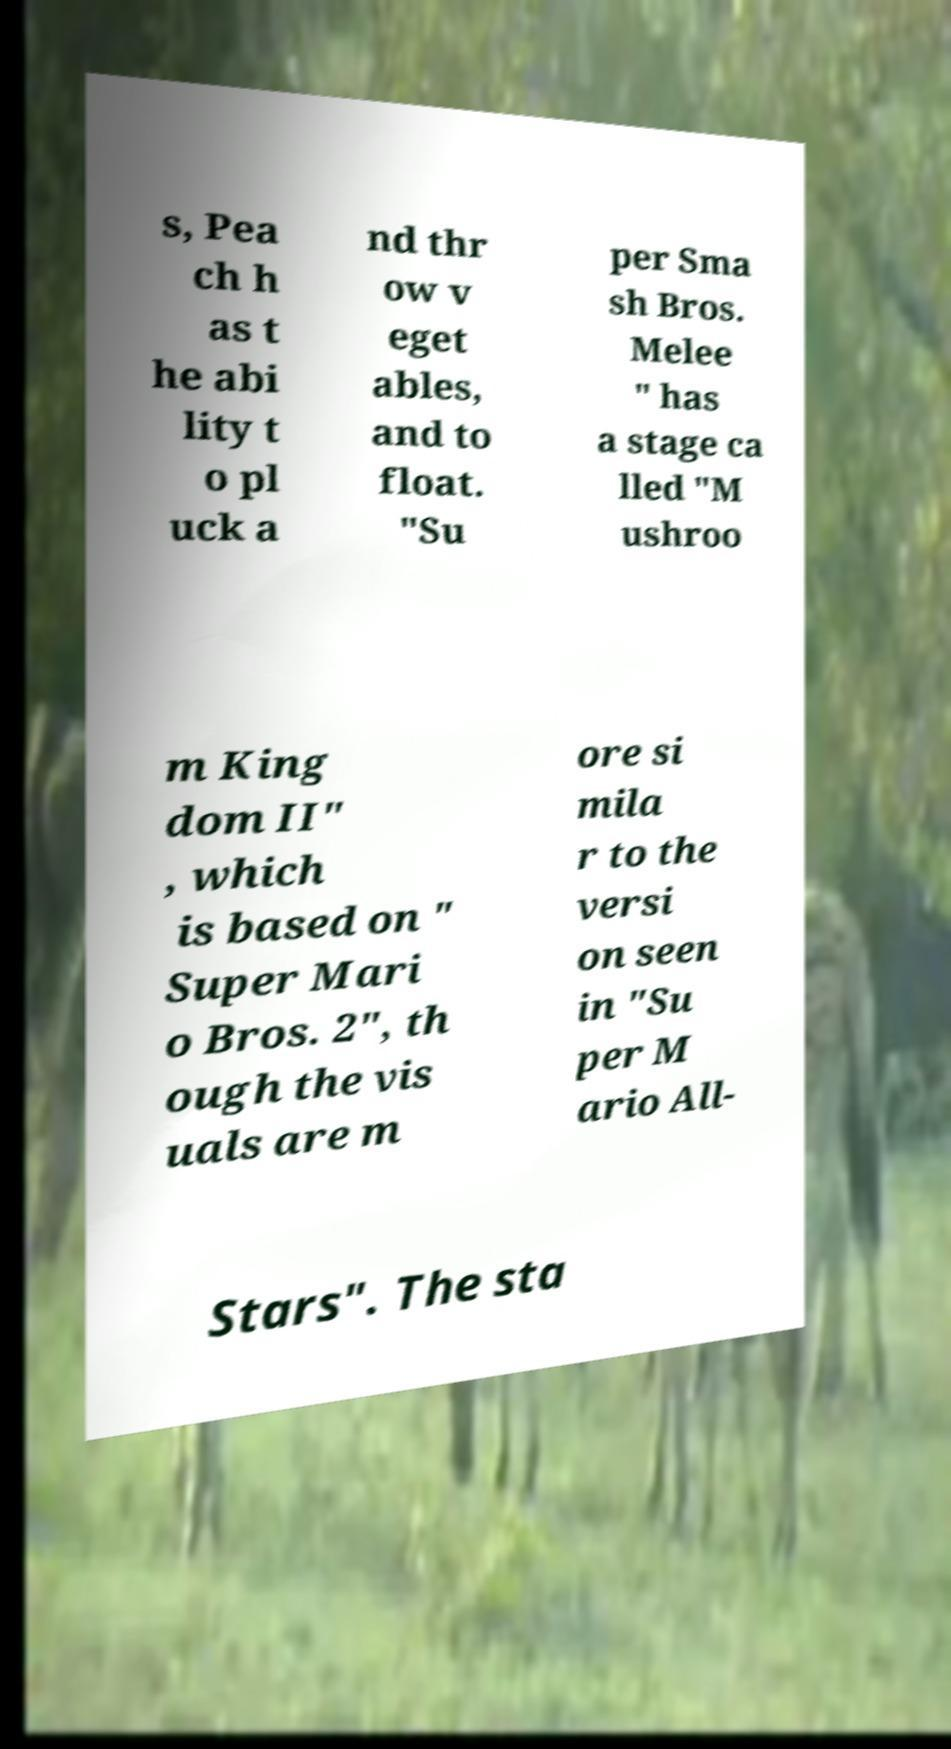What messages or text are displayed in this image? I need them in a readable, typed format. s, Pea ch h as t he abi lity t o pl uck a nd thr ow v eget ables, and to float. "Su per Sma sh Bros. Melee " has a stage ca lled "M ushroo m King dom II" , which is based on " Super Mari o Bros. 2", th ough the vis uals are m ore si mila r to the versi on seen in "Su per M ario All- Stars". The sta 